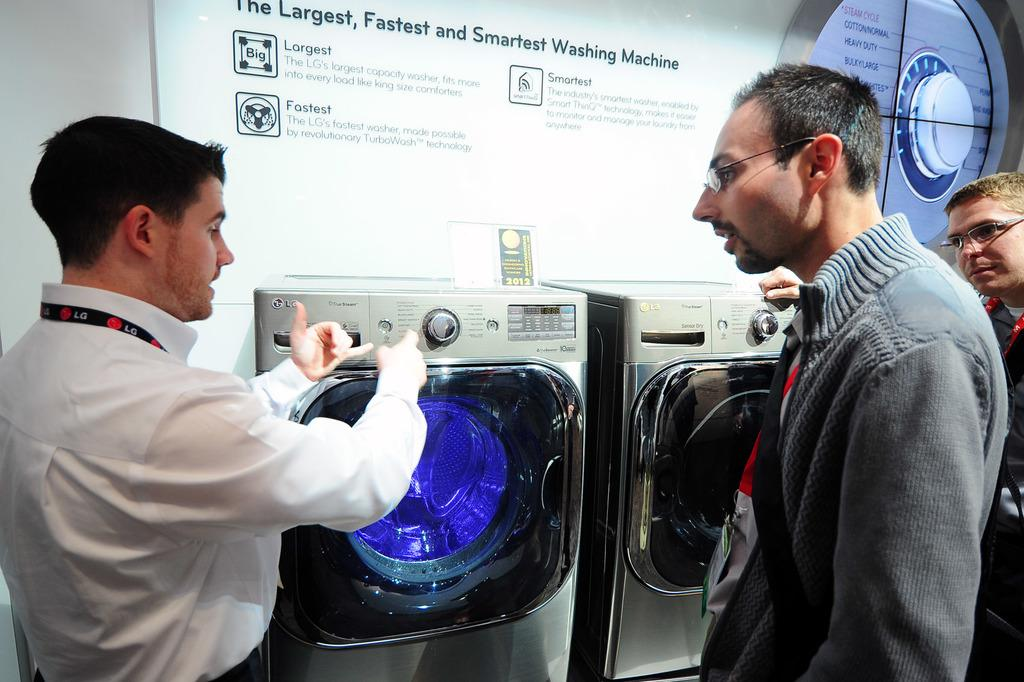How many people are in the image? There are persons standing in the image. What can be seen in the background of the image? There is a washing machine and a wall in the background of the image. What is on the wall in the background? There is a screen with text and a logo on the wall. Are the persons in the image coughing? There is no indication in the image that the persons are coughing. Can you see anyone swimming in the image? There is no swimming activity depicted in the image. 